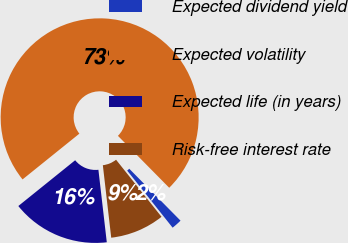Convert chart to OTSL. <chart><loc_0><loc_0><loc_500><loc_500><pie_chart><fcel>Expected dividend yield<fcel>Expected volatility<fcel>Expected life (in years)<fcel>Risk-free interest rate<nl><fcel>1.7%<fcel>73.39%<fcel>16.04%<fcel>8.87%<nl></chart> 